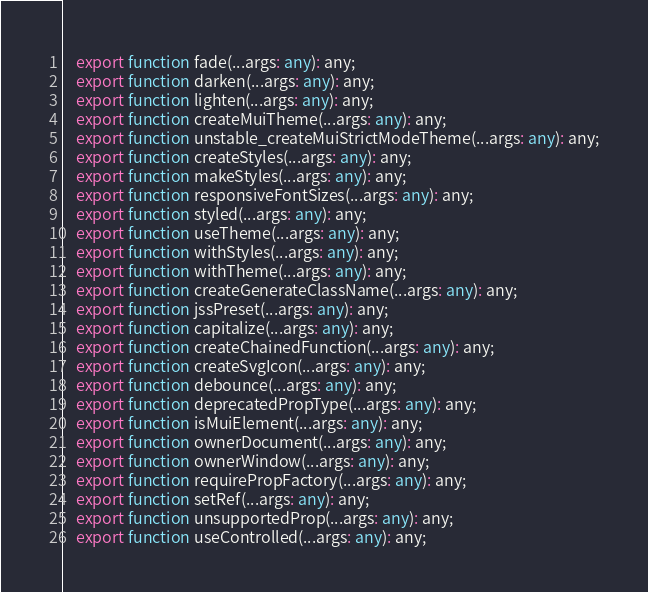Convert code to text. <code><loc_0><loc_0><loc_500><loc_500><_TypeScript_>    export function fade(...args: any): any;
    export function darken(...args: any): any;
    export function lighten(...args: any): any;
    export function createMuiTheme(...args: any): any;
    export function unstable_createMuiStrictModeTheme(...args: any): any;
    export function createStyles(...args: any): any;
    export function makeStyles(...args: any): any;
    export function responsiveFontSizes(...args: any): any;
    export function styled(...args: any): any;
    export function useTheme(...args: any): any;
    export function withStyles(...args: any): any;
    export function withTheme(...args: any): any;
    export function createGenerateClassName(...args: any): any;
    export function jssPreset(...args: any): any;
    export function capitalize(...args: any): any;
    export function createChainedFunction(...args: any): any;
    export function createSvgIcon(...args: any): any;
    export function debounce(...args: any): any;
    export function deprecatedPropType(...args: any): any;
    export function isMuiElement(...args: any): any;
    export function ownerDocument(...args: any): any;
    export function ownerWindow(...args: any): any;
    export function requirePropFactory(...args: any): any;
    export function setRef(...args: any): any;
    export function unsupportedProp(...args: any): any;
    export function useControlled(...args: any): any;</code> 